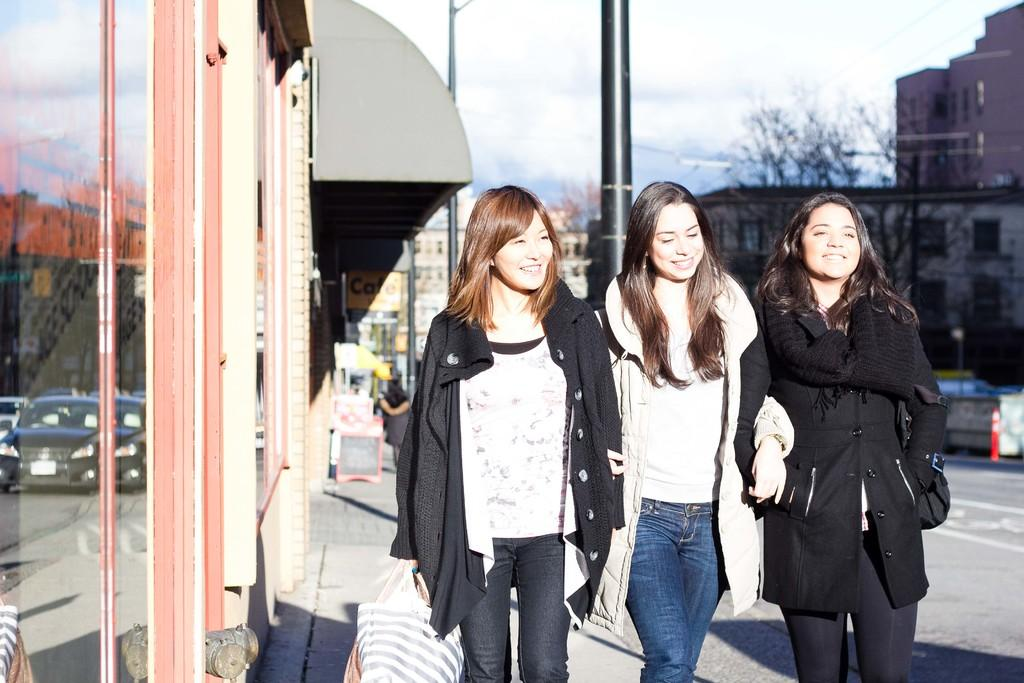How many ladies are present in the image? There are three ladies in the image. What are the ladies doing in the image? The ladies are walking on a footpath. What is located beside the footpath? There is a road beside the footpath. What can be seen on the left side of the image? There are shops on the left side of the image. What is visible in the background of the image? There are buildings and trees in the background of the image. Can you tell me who created the water in the image? There is no water present in the image, so it is not possible to determine who created it. 